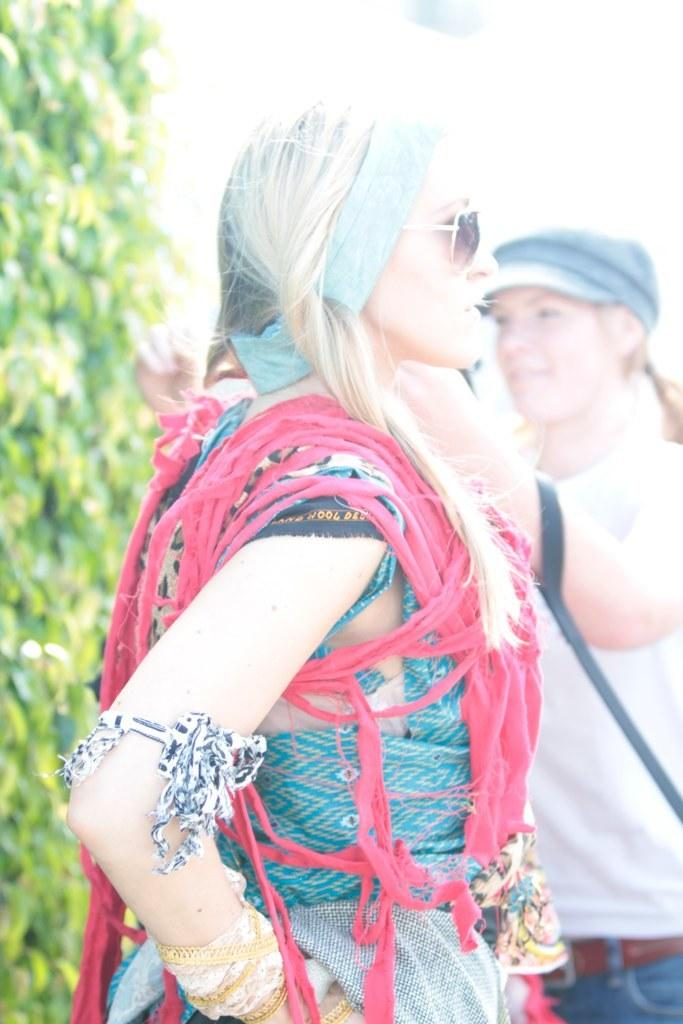How many people are present in the image? There are two persons standing in the image. What can be seen on the left side of the image? There is a tree on the left side of the image. Can you describe the person in the background of the image? The person in the background is wearing a cap. What type of roll is the person in the background eating in the image? There is no roll present in the image, and therefore no such activity can be observed. 